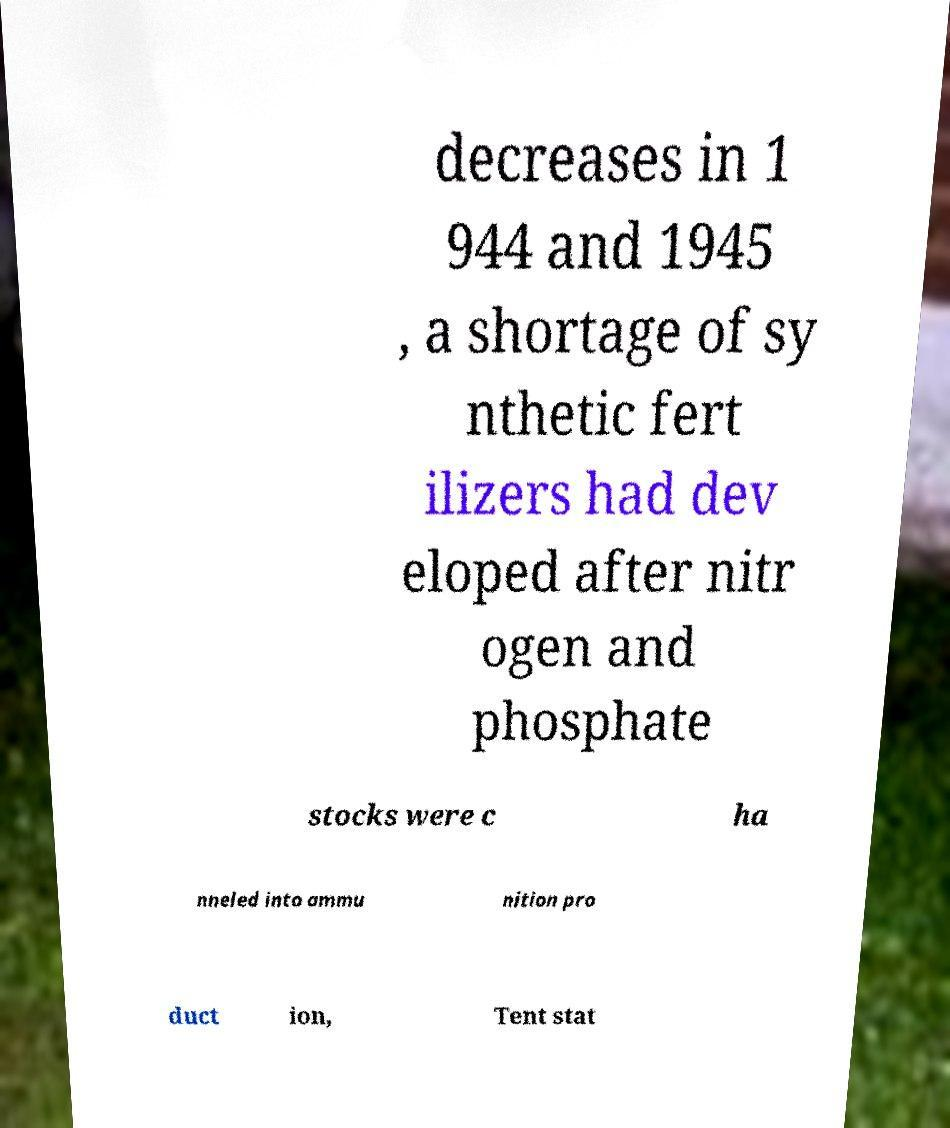I need the written content from this picture converted into text. Can you do that? decreases in 1 944 and 1945 , a shortage of sy nthetic fert ilizers had dev eloped after nitr ogen and phosphate stocks were c ha nneled into ammu nition pro duct ion, Tent stat 